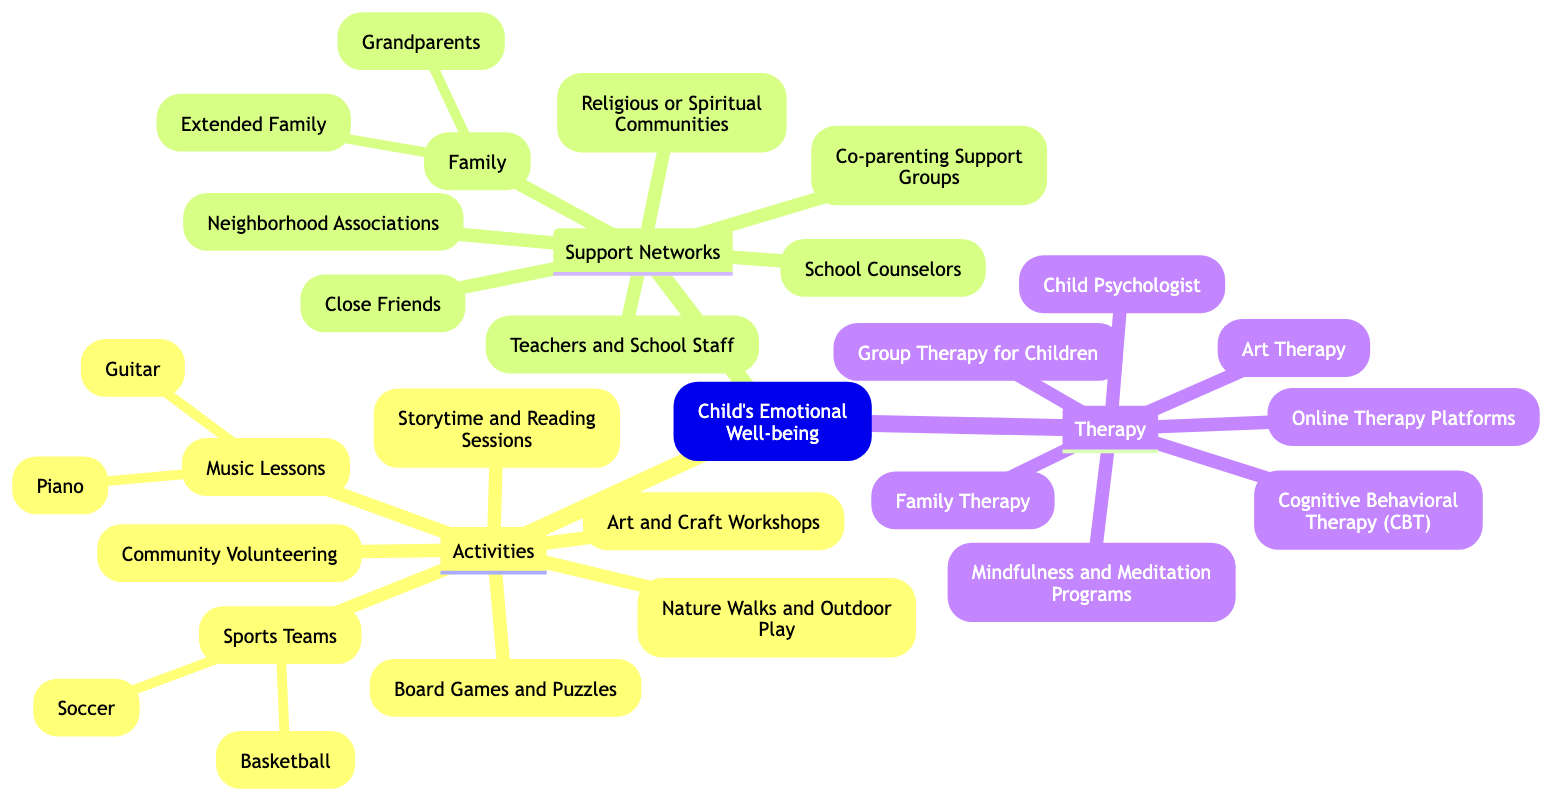What are the three main categories in the diagram? The diagram shows three main categories: Activities, Support Networks, and Therapy.
Answer: Activities, Support Networks, Therapy How many elements are listed under Activities? There are seven elements under the Activities category, which include various activities like Sports Teams, Art and Craft Workshops, and others.
Answer: 7 Which type of therapy is listed that focuses on group dynamics? The therapy focused on group dynamics is Group Therapy for Children, which is explicitly mentioned as one of the elements under the Therapy category.
Answer: Group Therapy for Children What is one element found in the Support Networks category? One element in the Support Networks category is Close Friends, which is listed as part of the support systems for a child's emotional well-being.
Answer: Close Friends Which type of therapy is related to creative expression? The therapy related to creative expression is Art Therapy, as it involves artistic activities to help children express their emotions.
Answer: Art Therapy How many nodes are there in the Therapy category? The Therapy category contains seven specific types of therapy listed, including Child Psychologist and Mindfulness Programs, indicating the variety of therapeutic options.
Answer: 7 Which support network involves community engagement? Neighborhood Associations represent a support network that involves community engagement, providing a local support system for the child's emotional well-being.
Answer: Neighborhood Associations What activity type includes Sports Teams? The category Activities includes Sports Teams, which has Soccer and Basketball as its elements, illustrating physical and team-based activities for children.
Answer: Sports Teams What is the relationship between Activities and Therapy categories? Both Activities and Therapy categories are subcategories contributing to the central node of Child's Emotional Well-being, highlighting different approaches to enhancing emotional health.
Answer: Both contribute to emotional well-being 